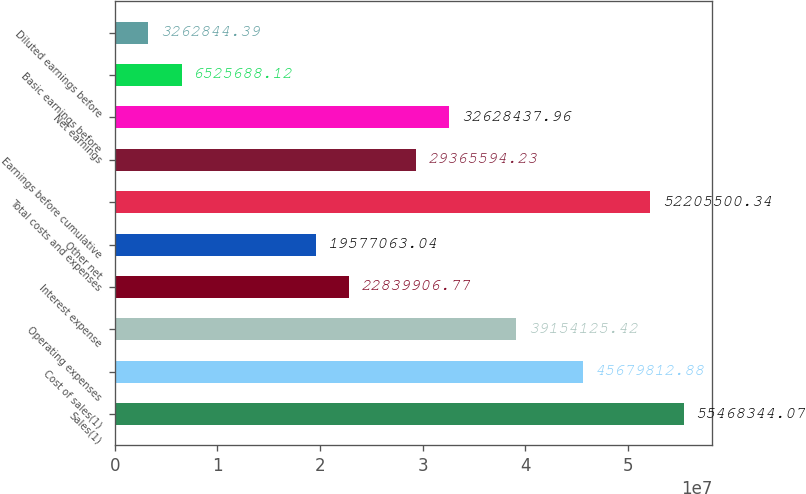<chart> <loc_0><loc_0><loc_500><loc_500><bar_chart><fcel>Sales(1)<fcel>Cost of sales(1)<fcel>Operating expenses<fcel>Interest expense<fcel>Other net<fcel>Total costs and expenses<fcel>Earnings before cumulative<fcel>Net earnings<fcel>Basic earnings before<fcel>Diluted earnings before<nl><fcel>5.54683e+07<fcel>4.56798e+07<fcel>3.91541e+07<fcel>2.28399e+07<fcel>1.95771e+07<fcel>5.22055e+07<fcel>2.93656e+07<fcel>3.26284e+07<fcel>6.52569e+06<fcel>3.26284e+06<nl></chart> 